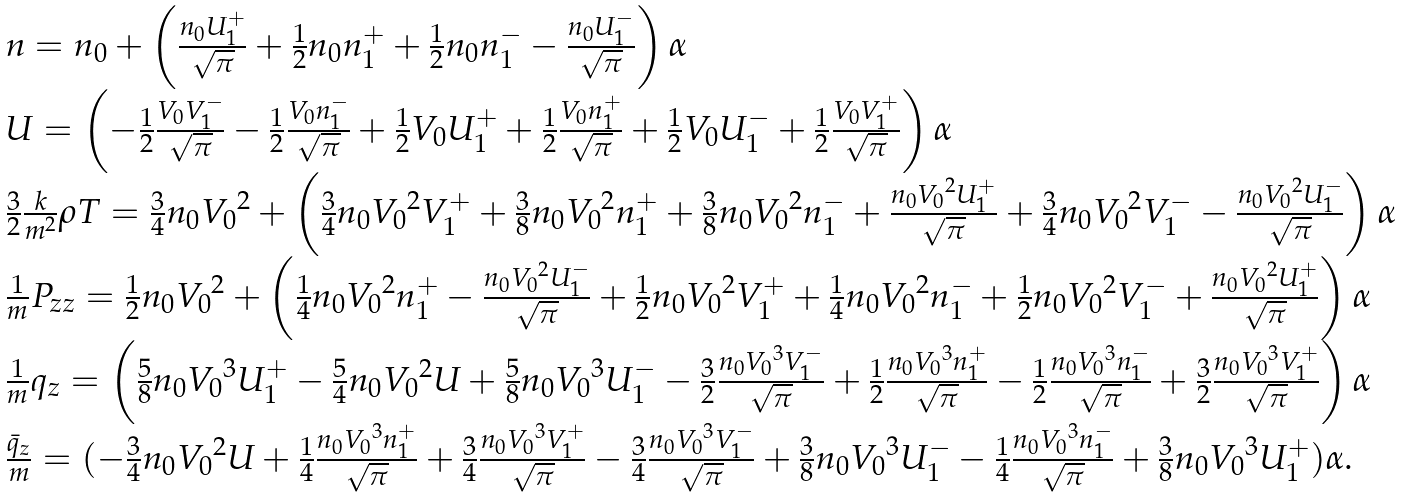<formula> <loc_0><loc_0><loc_500><loc_500>\begin{array} { l } n = n _ { 0 } + \left ( { \frac { n _ { 0 } U ^ { + } _ { 1 } } { \sqrt { \pi } } } + \frac { 1 } { 2 } n _ { 0 } n ^ { + } _ { 1 } + \frac { 1 } { 2 } n _ { 0 } n ^ { - } _ { 1 } - { \frac { n _ { 0 } U ^ { - } _ { 1 } } { \sqrt { \pi } } } \right ) \alpha \\ U = \left ( - \frac { 1 } { 2 } { \frac { V _ { 0 } V ^ { - } _ { 1 } } { \sqrt { \pi } } } - \frac { 1 } { 2 } { \frac { V _ { 0 } n ^ { - } _ { 1 } } { \sqrt { \pi } } } + \frac { 1 } { 2 } V _ { 0 } U ^ { + } _ { 1 } + \frac { 1 } { 2 } { \frac { V _ { 0 } n ^ { + } _ { 1 } } { \sqrt { \pi } } } + \frac { 1 } { 2 } V _ { 0 } U ^ { - } _ { 1 } + \frac { 1 } { 2 } { \frac { V _ { 0 } V ^ { + } _ { 1 } } { \sqrt { \pi } } } \right ) \alpha \\ \frac { 3 } { 2 } \frac { k } { m ^ { 2 } } \rho T = \frac { 3 } { 4 } n _ { 0 } { V _ { 0 } } ^ { 2 } + \left ( \frac { 3 } { 4 } n _ { 0 } { V _ { 0 } } ^ { 2 } V ^ { + } _ { 1 } + \frac { 3 } { 8 } n _ { 0 } { V _ { 0 } } ^ { 2 } n ^ { + } _ { 1 } + \frac { 3 } { 8 } n _ { 0 } { V _ { 0 } } ^ { 2 } n ^ { - } _ { 1 } + { \frac { n _ { 0 } { V _ { 0 } } ^ { 2 } U ^ { + } _ { 1 } } { \sqrt { \pi } } } + \frac { 3 } { 4 } n _ { 0 } { V _ { 0 } } ^ { 2 } V ^ { - } _ { 1 } - { \frac { n _ { 0 } { V _ { 0 } } ^ { 2 } U ^ { - } _ { 1 } } { \sqrt { \pi } } } \right ) \alpha \\ \frac { 1 } { m } P _ { z z } = \frac { 1 } { 2 } n _ { 0 } { V _ { 0 } } ^ { 2 } + \left ( \frac { 1 } { 4 } n _ { 0 } { V _ { 0 } } ^ { 2 } n ^ { + } _ { 1 } - { \frac { n _ { 0 } { V _ { 0 } } ^ { 2 } U ^ { - } _ { 1 } } { \sqrt { \pi } } } + \frac { 1 } { 2 } n _ { 0 } { V _ { 0 } } ^ { 2 } V ^ { + } _ { 1 } + \frac { 1 } { 4 } n _ { 0 } { V _ { 0 } } ^ { 2 } n ^ { - } _ { 1 } + \frac { 1 } { 2 } n _ { 0 } { V _ { 0 } } ^ { 2 } V ^ { - } _ { 1 } + { \frac { n _ { 0 } { V _ { 0 } } ^ { 2 } U ^ { + } _ { 1 } } { \sqrt { \pi } } } \right ) \alpha \\ \frac { 1 } { m } q _ { z } = \left ( \frac { 5 } { 8 } n _ { 0 } { V _ { 0 } } ^ { 3 } U ^ { + } _ { 1 } - \frac { 5 } { 4 } n _ { 0 } { V _ { 0 } } ^ { 2 } U + \frac { 5 } { 8 } n _ { 0 } { V _ { 0 } } ^ { 3 } U ^ { - } _ { 1 } - \frac { 3 } { 2 } { \frac { n _ { 0 } { V _ { 0 } } ^ { 3 } V ^ { - } _ { 1 } } { \sqrt { \pi } } } + \frac { 1 } { 2 } { \frac { n _ { 0 } { V _ { 0 } } ^ { 3 } n ^ { + } _ { 1 } } { \sqrt { \pi } } } - \frac { 1 } { 2 } { \frac { n _ { 0 } { V _ { 0 } } ^ { 3 } n ^ { - } _ { 1 } } { \sqrt { \pi } } } + \frac { 3 } { 2 } { \frac { n _ { 0 } { V _ { 0 } } ^ { 3 } V ^ { + } _ { 1 } } { \sqrt { \pi } } } \right ) \alpha \\ \frac { \bar { q } _ { z } } { m } = ( - \frac { 3 } { 4 } n _ { 0 } { V _ { 0 } } ^ { 2 } U + \frac { 1 } { 4 } { \frac { n _ { 0 } { V _ { 0 } } ^ { 3 } n ^ { + } _ { 1 } } { \sqrt { \pi } } } + \frac { 3 } { 4 } { \frac { n _ { 0 } { V _ { 0 } } ^ { 3 } V ^ { + } _ { 1 } } { \sqrt { \pi } } } - \frac { 3 } { 4 } { \frac { n _ { 0 } { V _ { 0 } } ^ { 3 } V ^ { - } _ { 1 } } { \sqrt { \pi } } } + \frac { 3 } { 8 } n _ { 0 } { V _ { 0 } } ^ { 3 } U ^ { - } _ { 1 } - \frac { 1 } { 4 } { \frac { n _ { 0 } { V _ { 0 } } ^ { 3 } n ^ { - } _ { 1 } } { \sqrt { \pi } } } + \frac { 3 } { 8 } n _ { 0 } { V _ { 0 } } ^ { 3 } U ^ { + } _ { 1 } ) \alpha . \end{array}</formula> 